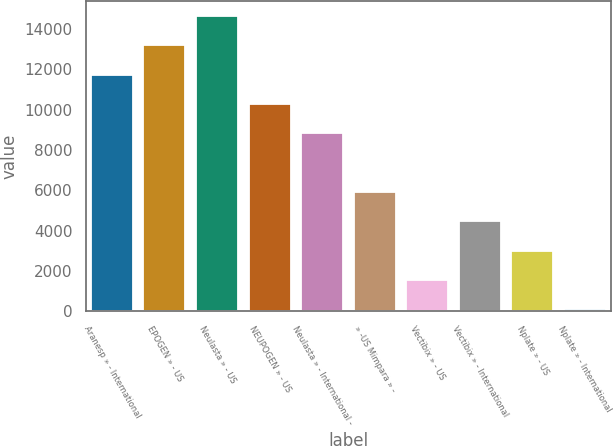Convert chart. <chart><loc_0><loc_0><loc_500><loc_500><bar_chart><fcel>Aranesp » - International<fcel>EPOGEN » - US<fcel>Neulasta » - US<fcel>NEUPOGEN » - US<fcel>Neulasta » - International -<fcel>» -US Mimpara » -<fcel>Vectibix » - US<fcel>Vectibix » - International<fcel>Nplate » - US<fcel>Nplate » - International<nl><fcel>11748<fcel>13204<fcel>14660<fcel>10292<fcel>8836<fcel>5924<fcel>1556<fcel>4468<fcel>3012<fcel>100<nl></chart> 